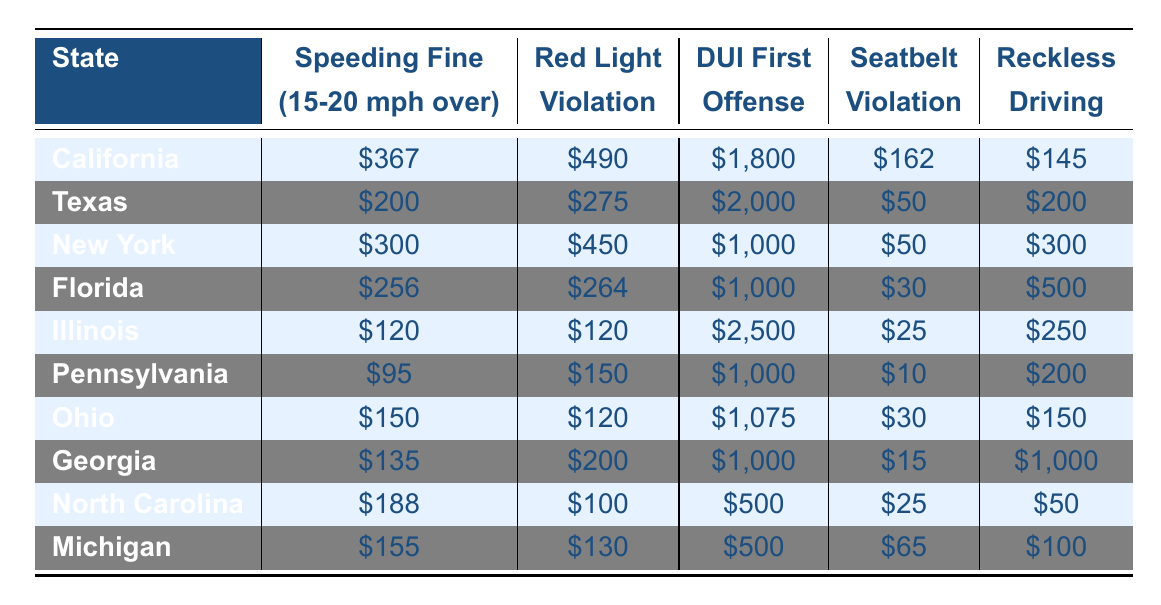What is the highest speeding fine listed in the table? By checking the "Speeding Fine (15-20 mph over)" column, California has the highest speeding fine at $367.
Answer: $367 Which state has the lowest seatbelt violation fine? In the "Seatbelt Violation" column, Pennsylvania has the lowest fine at $10.
Answer: $10 What is the total fine for a DUI first offense and reckless driving in Illinois? In Illinois, the DUI first offense fine is $2,500 and the reckless driving fine is $250. Summing these gives $2,500 + $250 = $2,750.
Answer: $2,750 Is the red light violation fine higher in Florida than in Ohio? Florida has a red light violation fine of $264 while Ohio's fine is $120, thus Florida's fine is higher.
Answer: Yes Which state has the highest total of fines for all violations mentioned? The total fines must be calculated for each state: California ($367 + $490 + $1,800 + $162 + $145 = $2,964), Texas ($200 + $275 + $2,000 + $50 + $200 = $2,725), New York ($300 + $450 + $1,000 + $50 + $300 = $2,100), Florida ($256 + $264 + $1,000 + $30 + $500 = $2,050), Illinois ($120 + $120 + $2,500 + $25 + $250 = $3,015), Pennsylvania ($95 + $150 + $1,000 + $10 + $200 = $1,455), Ohio ($150 + $120 + $1,075 + $30 + $150 = $1,525), Georgia ($135 + $200 + $1,000 + $15 + $1,000 = $2,350), North Carolina ($188 + $100 + $500 + $25 + $50 = $863), Michigan ($155 + $130 + $500 + $65 + $100 = $950). The highest total is Illinois with $3,015.
Answer: Illinois What is the average speeding fine across all states? The speeding fines are: $367, $200, $300, $256, $120, $95, $150, $135, $188, $155. Summing these gives $2,871, and dividing by 10 (the number of states), we get $287.10.
Answer: $287.10 Are the fines for reckless driving in Georgia higher than those in North Carolina? Georgia has a reckless driving fine of $1,000, while North Carolina's fine is $50. Therefore, Georgia’s fine is higher.
Answer: Yes Which two states have the same red light violation fine? By looking at the "Red Light Violation" column, both Illinois and Ohio have a fine of $120.
Answer: Illinois and Ohio What is the difference in DUI first offense fines between Texas and Michigan? The DUI first offense fine in Texas is $2,000 and in Michigan it is $500. The difference is $2,000 - $500 = $1,500.
Answer: $1,500 What percentage of the speeding fine in New York is the seatbelt violation fine? The speeding fine in New York is $300 and the seatbelt violation fine is $50. Calculating the percentage gives ($50 / $300) * 100 = 16.67%.
Answer: 16.67% Which state has a speeding fine that is more than $300 but less than $400? Reviewing the speeding fines, California ($367) fits this criterion as it is greater than $300 and less than $400.
Answer: California 